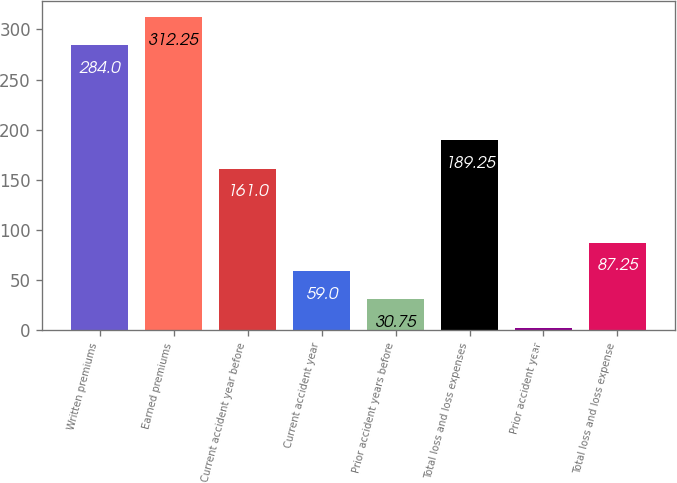Convert chart to OTSL. <chart><loc_0><loc_0><loc_500><loc_500><bar_chart><fcel>Written premiums<fcel>Earned premiums<fcel>Current accident year before<fcel>Current accident year<fcel>Prior accident years before<fcel>Total loss and loss expenses<fcel>Prior accident year<fcel>Total loss and loss expense<nl><fcel>284<fcel>312.25<fcel>161<fcel>59<fcel>30.75<fcel>189.25<fcel>2.5<fcel>87.25<nl></chart> 